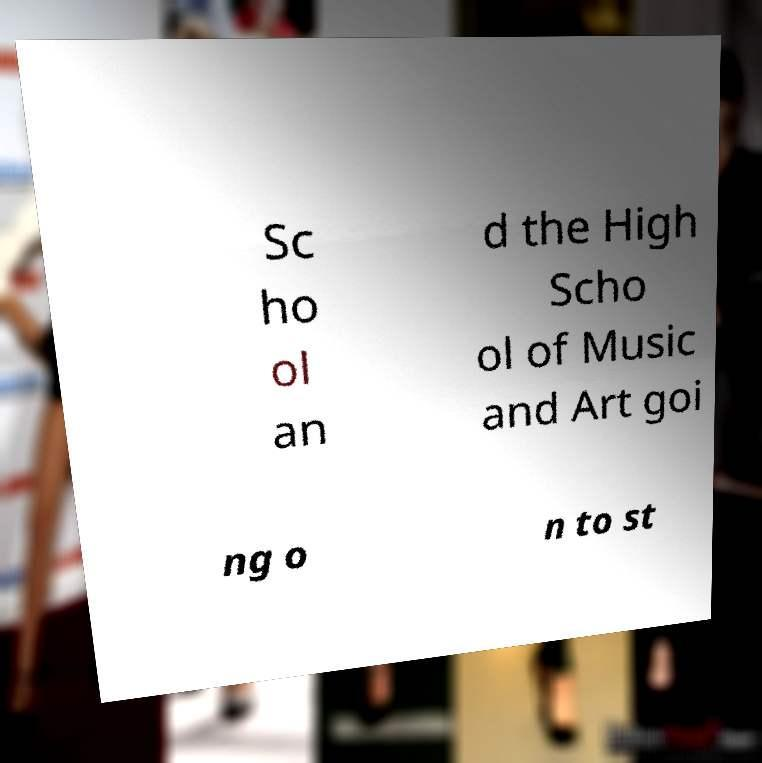For documentation purposes, I need the text within this image transcribed. Could you provide that? Sc ho ol an d the High Scho ol of Music and Art goi ng o n to st 